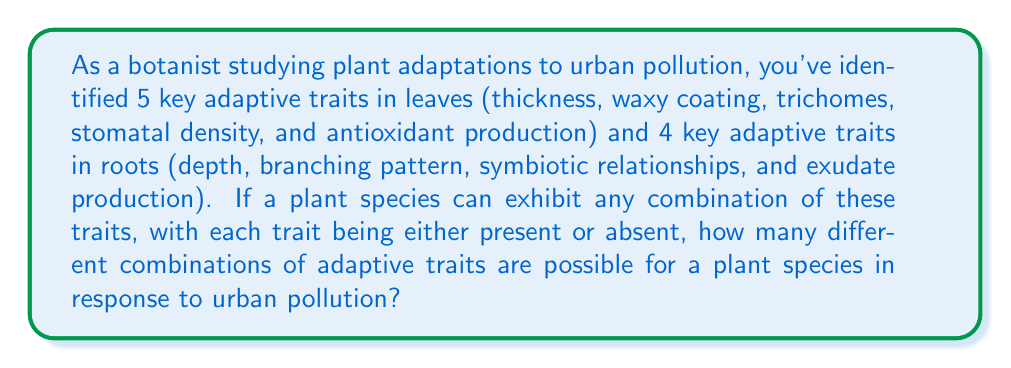Can you solve this math problem? To solve this problem, we need to use the multiplication principle of counting. Here's a step-by-step explanation:

1. For each trait, there are two possibilities: present or absent.

2. There are 5 leaf traits and 4 root traits, for a total of 9 traits.

3. For each trait, we have 2 choices (present or absent), and this is true for all 9 traits.

4. According to the multiplication principle, if we have a series of independent choices, we multiply the number of possibilities for each choice.

5. Therefore, the total number of possible combinations is:

   $$2^9 = 2 \times 2 \times 2 \times 2 \times 2 \times 2 \times 2 \times 2 \times 2$$

6. We can calculate this as:

   $$2^9 = 512$$

This means that there are 512 possible combinations of adaptive traits that a plant species could exhibit in response to urban pollution, based on the presence or absence of the 9 identified key traits.
Answer: $512$ possible combinations 